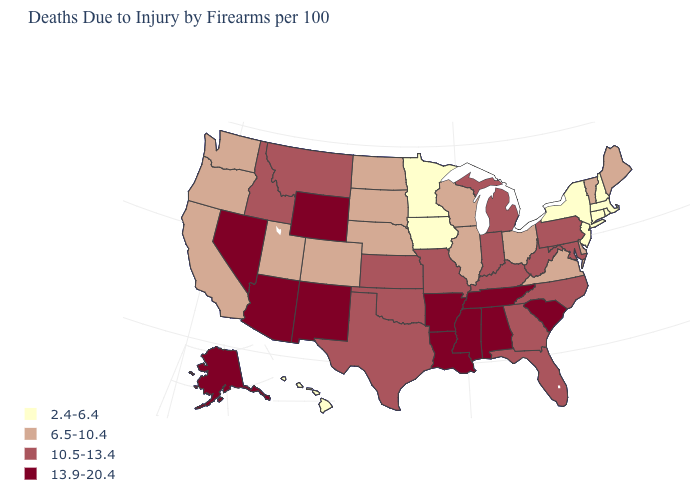Which states hav the highest value in the West?
Keep it brief. Alaska, Arizona, Nevada, New Mexico, Wyoming. Name the states that have a value in the range 2.4-6.4?
Short answer required. Connecticut, Hawaii, Iowa, Massachusetts, Minnesota, New Hampshire, New Jersey, New York, Rhode Island. What is the value of Georgia?
Short answer required. 10.5-13.4. What is the value of Georgia?
Write a very short answer. 10.5-13.4. Is the legend a continuous bar?
Be succinct. No. What is the value of West Virginia?
Keep it brief. 10.5-13.4. Among the states that border Delaware , which have the highest value?
Concise answer only. Maryland, Pennsylvania. What is the value of West Virginia?
Give a very brief answer. 10.5-13.4. Does the map have missing data?
Be succinct. No. Name the states that have a value in the range 10.5-13.4?
Write a very short answer. Florida, Georgia, Idaho, Indiana, Kansas, Kentucky, Maryland, Michigan, Missouri, Montana, North Carolina, Oklahoma, Pennsylvania, Texas, West Virginia. Which states hav the highest value in the West?
Be succinct. Alaska, Arizona, Nevada, New Mexico, Wyoming. Does the map have missing data?
Answer briefly. No. What is the value of Indiana?
Quick response, please. 10.5-13.4. Which states have the highest value in the USA?
Quick response, please. Alabama, Alaska, Arizona, Arkansas, Louisiana, Mississippi, Nevada, New Mexico, South Carolina, Tennessee, Wyoming. What is the highest value in states that border Wisconsin?
Give a very brief answer. 10.5-13.4. 